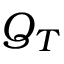<formula> <loc_0><loc_0><loc_500><loc_500>Q _ { T }</formula> 